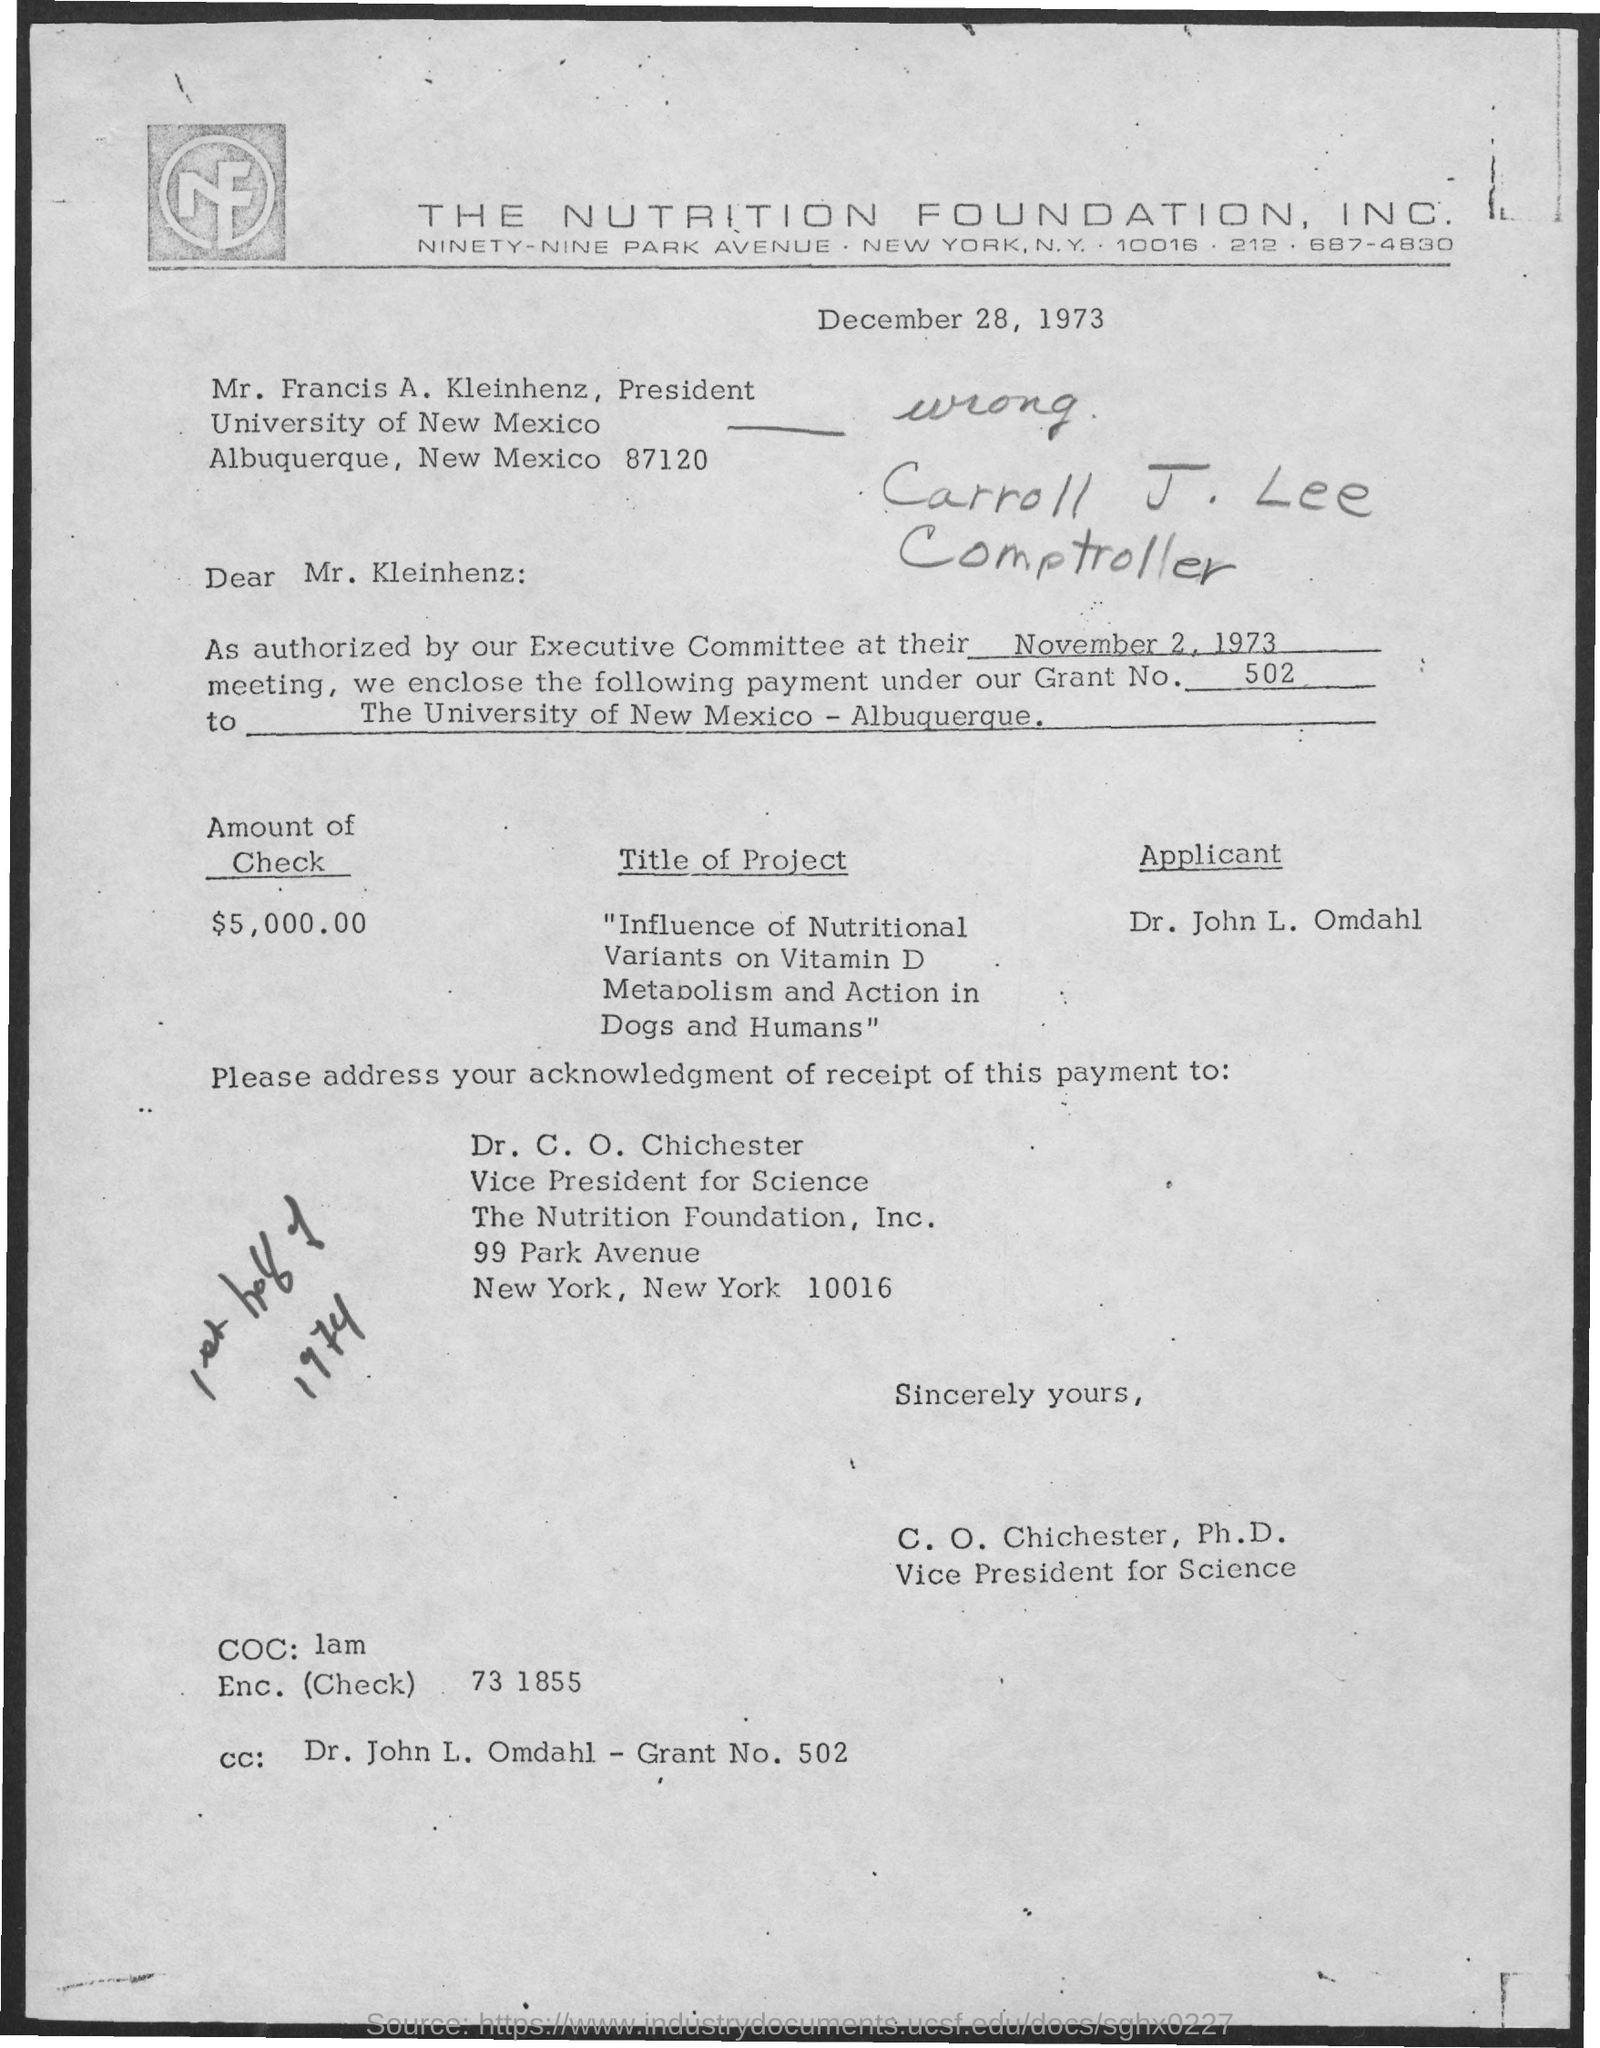What is the amount of check given in the letter ?
Offer a terse response. $5,000.00. What is the grant number mentioned in the given letter ?
Provide a succinct answer. 502. What is the title of the project given in the letter ?
Offer a terse response. "influence of nutritional variants on vitamin D metabolism and action in dogs and humans". What is the designation of c.o. chichester ?
Offer a very short reply. Vice President for Science. What is the name of the university mentioned in the given letter ?
Offer a very short reply. University of new mexico. 